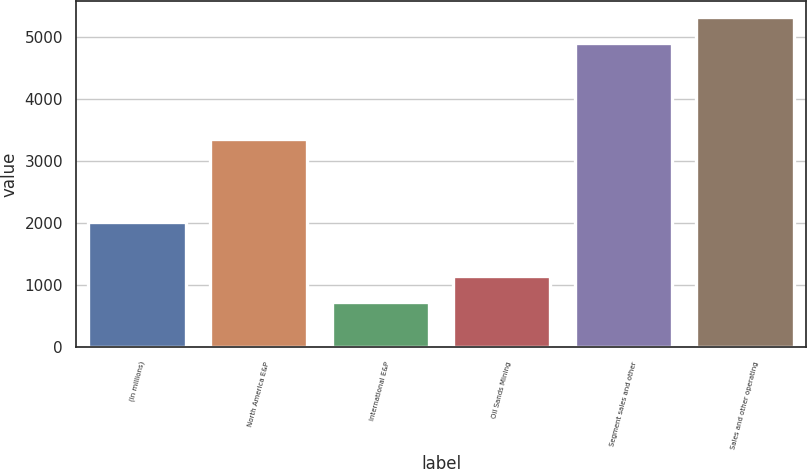Convert chart to OTSL. <chart><loc_0><loc_0><loc_500><loc_500><bar_chart><fcel>(In millions)<fcel>North America E&P<fcel>International E&P<fcel>Oil Sands Mining<fcel>Segment sales and other<fcel>Sales and other operating<nl><fcel>2015<fcel>3358<fcel>728<fcel>1150.3<fcel>4901<fcel>5323.3<nl></chart> 